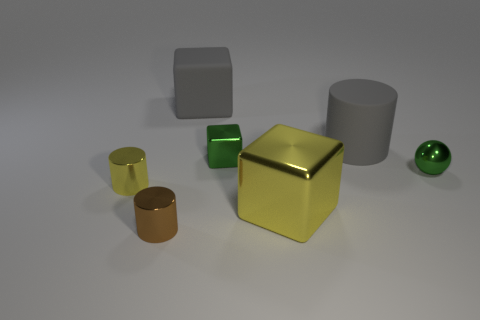Add 2 purple shiny cubes. How many objects exist? 9 Subtract all spheres. How many objects are left? 6 Subtract all tiny blue shiny spheres. Subtract all balls. How many objects are left? 6 Add 5 large yellow objects. How many large yellow objects are left? 6 Add 6 large cyan cylinders. How many large cyan cylinders exist? 6 Subtract 0 blue balls. How many objects are left? 7 